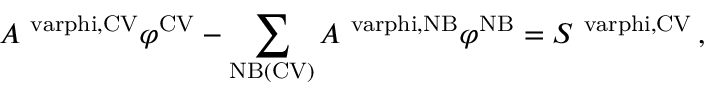<formula> <loc_0><loc_0><loc_500><loc_500>A ^ { \ v a r p h i , C V } \varphi ^ { C V } - \sum _ { N B ( C V ) } A ^ { \ v a r p h i , N B } \varphi ^ { N B } = S ^ { \ v a r p h i , C V } \, ,</formula> 